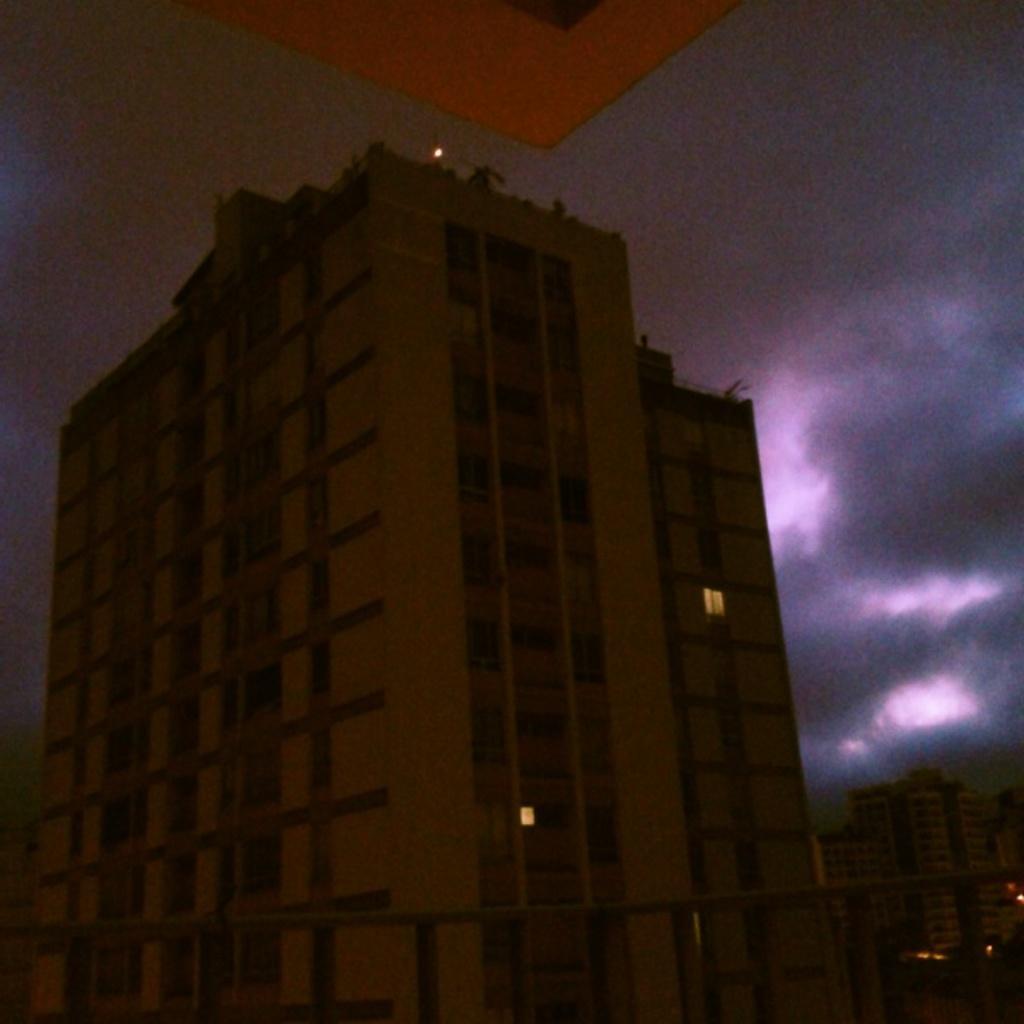Please provide a concise description of this image. In this image there is a building, in the background there is the sky, in front of the building there is the sky. 